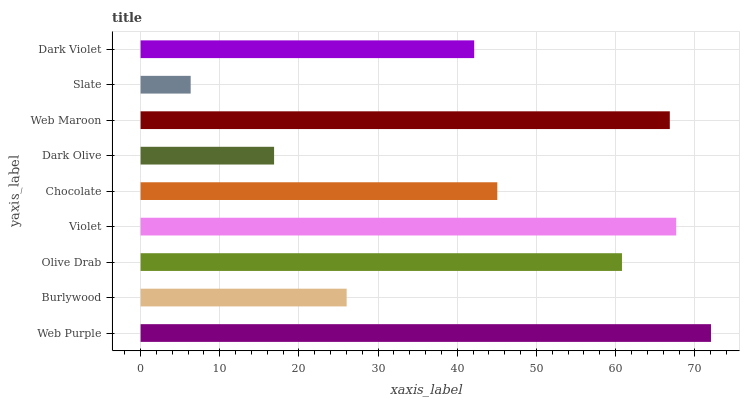Is Slate the minimum?
Answer yes or no. Yes. Is Web Purple the maximum?
Answer yes or no. Yes. Is Burlywood the minimum?
Answer yes or no. No. Is Burlywood the maximum?
Answer yes or no. No. Is Web Purple greater than Burlywood?
Answer yes or no. Yes. Is Burlywood less than Web Purple?
Answer yes or no. Yes. Is Burlywood greater than Web Purple?
Answer yes or no. No. Is Web Purple less than Burlywood?
Answer yes or no. No. Is Chocolate the high median?
Answer yes or no. Yes. Is Chocolate the low median?
Answer yes or no. Yes. Is Olive Drab the high median?
Answer yes or no. No. Is Violet the low median?
Answer yes or no. No. 